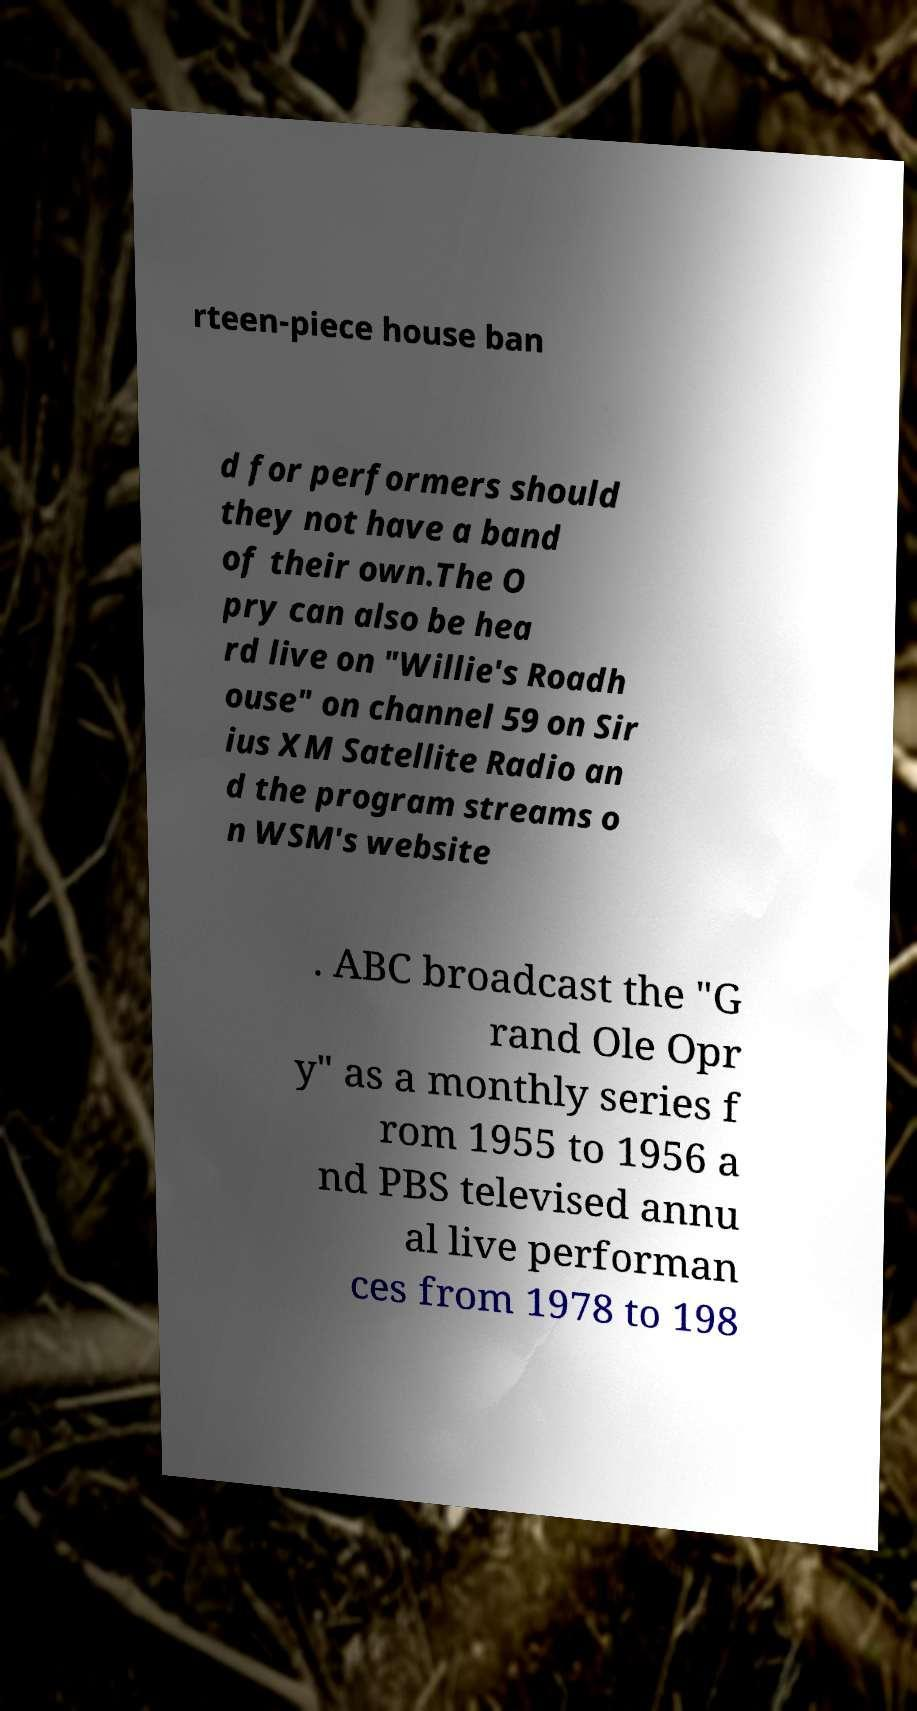Can you accurately transcribe the text from the provided image for me? rteen-piece house ban d for performers should they not have a band of their own.The O pry can also be hea rd live on "Willie's Roadh ouse" on channel 59 on Sir ius XM Satellite Radio an d the program streams o n WSM's website . ABC broadcast the "G rand Ole Opr y" as a monthly series f rom 1955 to 1956 a nd PBS televised annu al live performan ces from 1978 to 198 